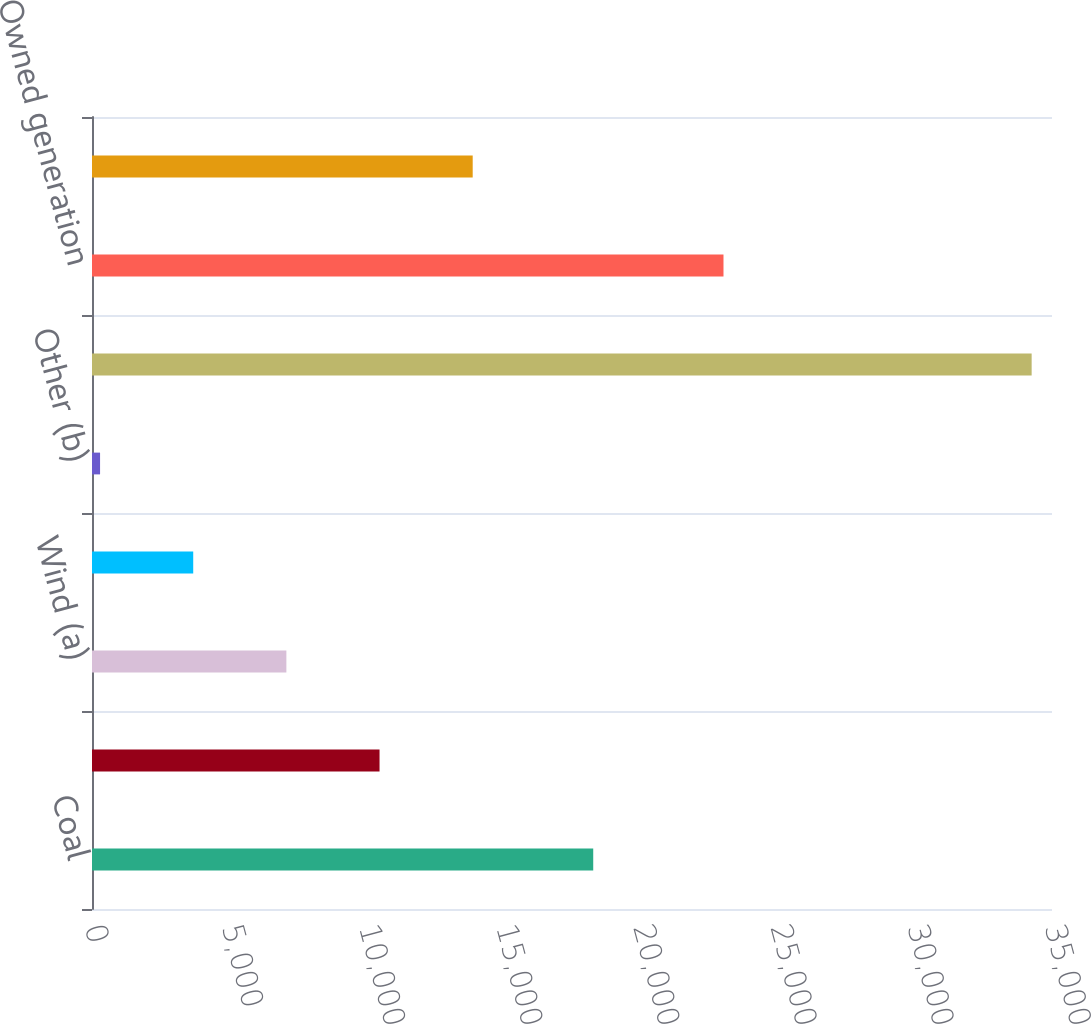Convert chart to OTSL. <chart><loc_0><loc_0><loc_500><loc_500><bar_chart><fcel>Coal<fcel>Natural Gas<fcel>Wind (a)<fcel>Hydroelectric<fcel>Other (b)<fcel>Total<fcel>Owned generation<fcel>Purchased generation<nl><fcel>18274<fcel>10483.2<fcel>7086.8<fcel>3690.4<fcel>294<fcel>34258<fcel>23023<fcel>13879.6<nl></chart> 